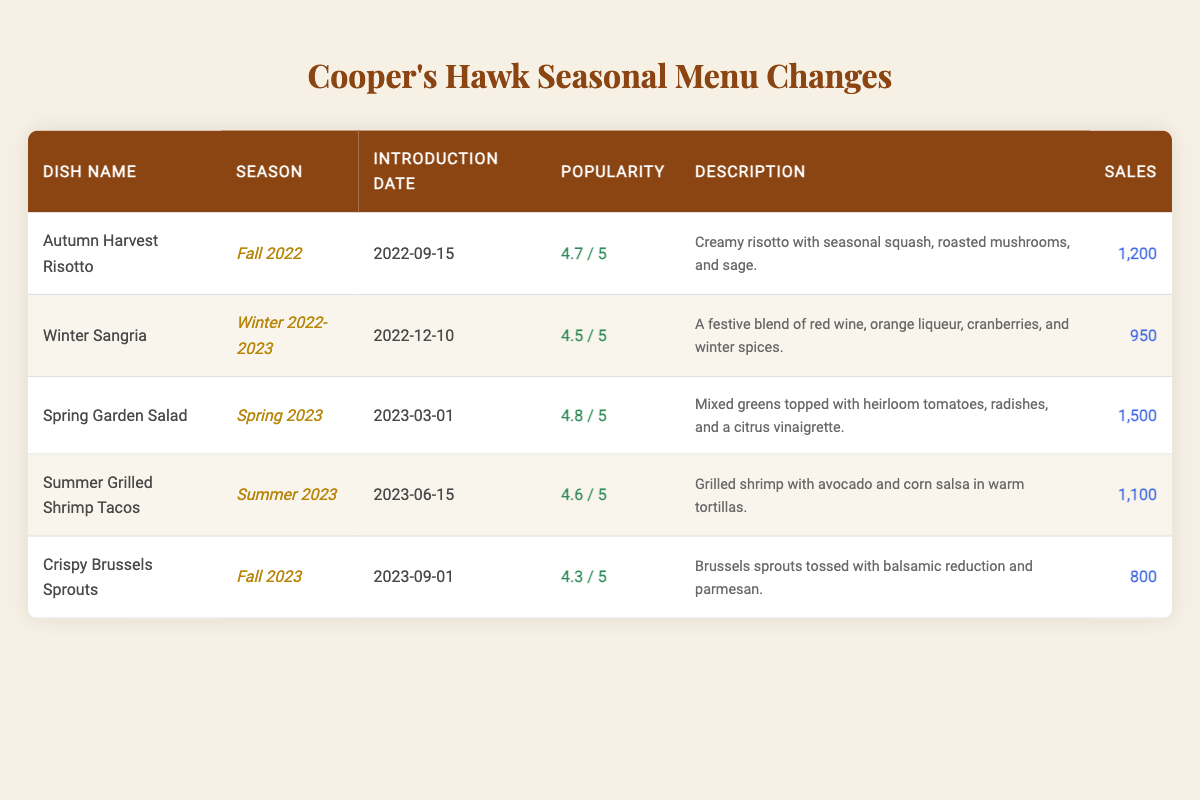What is the popularity rating of the Spring Garden Salad? The table shows that the popularity rating for the Spring Garden Salad is listed under the "Popularity" column, and it is 4.8.
Answer: 4.8 Which dish was introduced in Winter 2022-2023? By looking at the "Season" column, the dish listed for Winter 2022-2023 is the Winter Sangria, which has an introduction date of 2022-12-10.
Answer: Winter Sangria What is the sales figure for the Crispy Brussels Sprouts? The sales figure for the Crispy Brussels Sprouts is located in the last column of the table, which notes that 800 units were sold.
Answer: 800 Which seasonal dish had the highest sales? By comparing the sales figures listed next to each dish, the Spring Garden Salad has the highest sales at 1,500 units sold, surpassing all others.
Answer: Spring Garden Salad Is the Autumn Harvest Risotto more popular than the Winter Sangria? The popularity rating for the Autumn Harvest Risotto is 4.7, whereas the Winter Sangria has a popularity rating of 4.5. Since 4.7 is greater than 4.5, the Autumn Harvest Risotto is indeed more popular.
Answer: Yes What is the average popularity rating of the dishes listed in the table? To find the average, sum all the popularity ratings (4.7 + 4.5 + 4.8 + 4.6 + 4.3 = 23.9) and then divide by the number of dishes (5). Thus, the average popularity rating is 23.9 / 5 = 4.78.
Answer: 4.78 How many dishes were introduced during the Spring season? The table indicates that one dish, the Spring Garden Salad, is explicitly listed for Spring 2023, so there is only one dish for this season.
Answer: 1 Which dish saw the least sales? Looking through the "Sales" column, the Crispy Brussels Sprouts had the least sales figure at 800, which is lower than all other dishes.
Answer: Crispy Brussels Sprouts Did the popularity ratings of dishes generally increase over the seasons? Reviewing the popularity ratings for each dish in their respective seasons, we observe the ratings: Fall 2022 (4.7), Winter 2022-2023 (4.5), Spring 2023 (4.8), Summer 2023 (4.6), Fall 2023 (4.3). While there is a peak in Spring 2023, the ratings do not consistently increase or decrease, so the answer is no.
Answer: No What is the total sales figure across all seasonal dishes? To find the total sales, sum all the sales figures from the table: 1200 + 950 + 1500 + 1100 + 800 = 4550. The total sales figure across all dishes is 4550.
Answer: 4550 